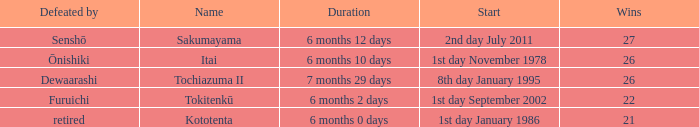Which duration was defeated by retired? 6 months 0 days. 